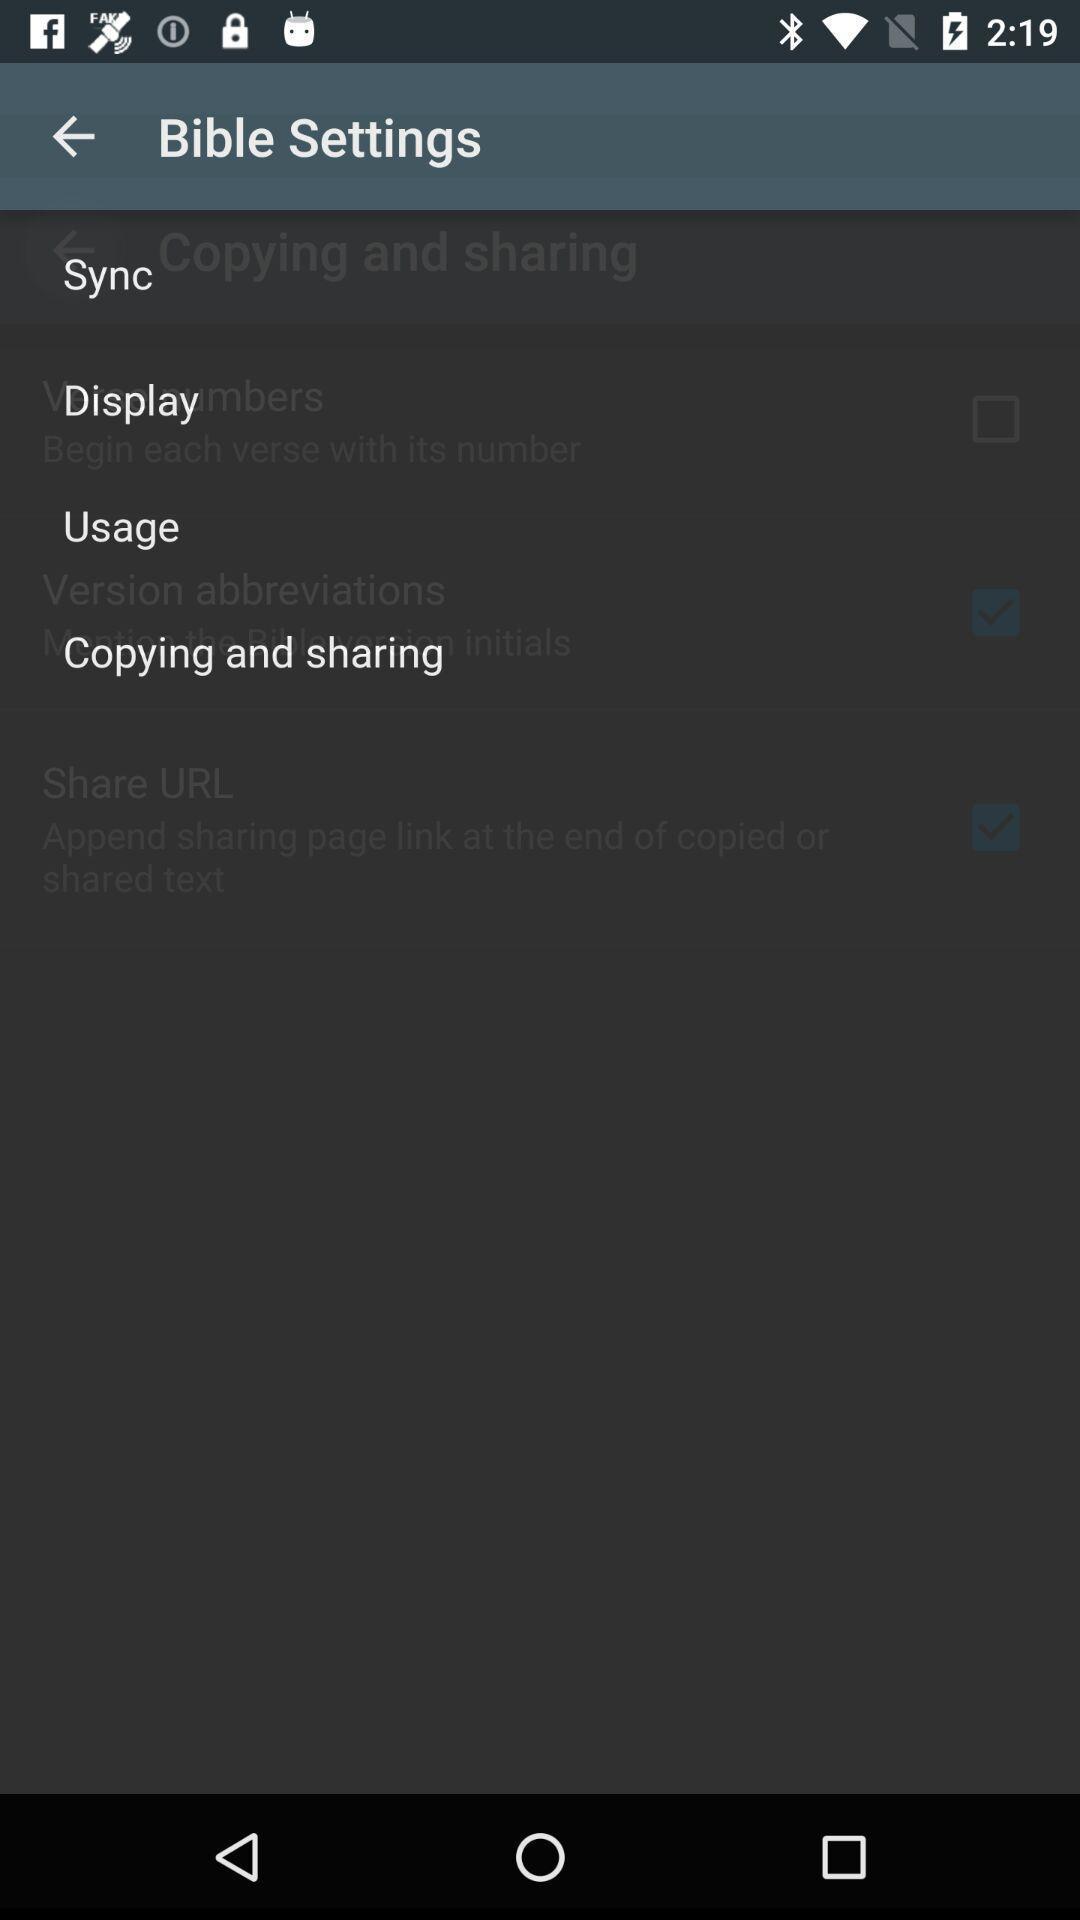Explain the elements present in this screenshot. Settings page. 